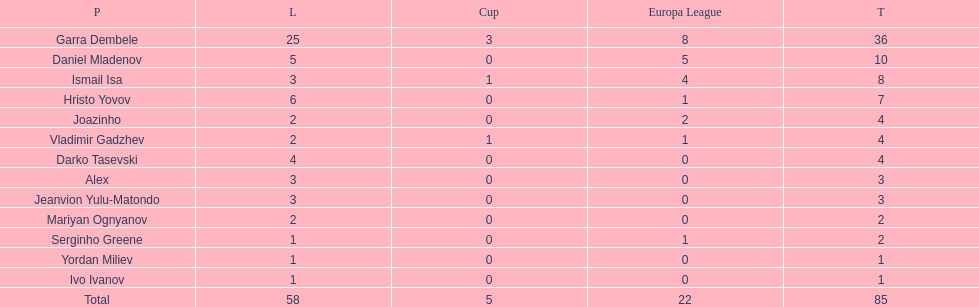Which total is higher, the europa league total or the league total? League. 